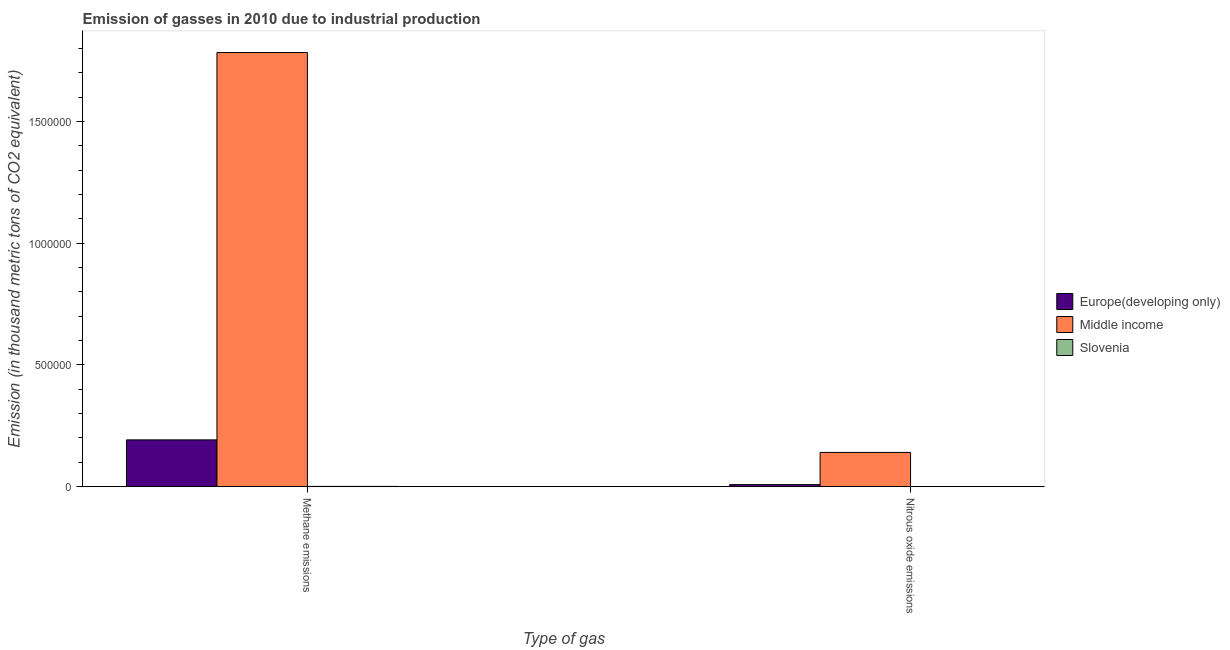Are the number of bars on each tick of the X-axis equal?
Ensure brevity in your answer.  Yes. How many bars are there on the 1st tick from the left?
Offer a very short reply. 3. How many bars are there on the 2nd tick from the right?
Ensure brevity in your answer.  3. What is the label of the 1st group of bars from the left?
Give a very brief answer. Methane emissions. What is the amount of nitrous oxide emissions in Europe(developing only)?
Offer a very short reply. 8539.4. Across all countries, what is the maximum amount of nitrous oxide emissions?
Keep it short and to the point. 1.41e+05. Across all countries, what is the minimum amount of methane emissions?
Your response must be concise. 1225.8. In which country was the amount of methane emissions maximum?
Provide a short and direct response. Middle income. In which country was the amount of methane emissions minimum?
Provide a succinct answer. Slovenia. What is the total amount of methane emissions in the graph?
Make the answer very short. 1.98e+06. What is the difference between the amount of nitrous oxide emissions in Slovenia and that in Middle income?
Keep it short and to the point. -1.41e+05. What is the difference between the amount of methane emissions in Middle income and the amount of nitrous oxide emissions in Europe(developing only)?
Ensure brevity in your answer.  1.77e+06. What is the average amount of nitrous oxide emissions per country?
Your answer should be compact. 4.98e+04. What is the difference between the amount of nitrous oxide emissions and amount of methane emissions in Slovenia?
Offer a terse response. -1091.4. In how many countries, is the amount of methane emissions greater than 100000 thousand metric tons?
Keep it short and to the point. 2. What is the ratio of the amount of methane emissions in Slovenia to that in Middle income?
Your response must be concise. 0. What does the 3rd bar from the left in Methane emissions represents?
Keep it short and to the point. Slovenia. How many bars are there?
Offer a terse response. 6. How many countries are there in the graph?
Make the answer very short. 3. Are the values on the major ticks of Y-axis written in scientific E-notation?
Keep it short and to the point. No. Does the graph contain grids?
Your answer should be very brief. No. Where does the legend appear in the graph?
Provide a succinct answer. Center right. How are the legend labels stacked?
Provide a succinct answer. Vertical. What is the title of the graph?
Offer a terse response. Emission of gasses in 2010 due to industrial production. What is the label or title of the X-axis?
Your response must be concise. Type of gas. What is the label or title of the Y-axis?
Your answer should be very brief. Emission (in thousand metric tons of CO2 equivalent). What is the Emission (in thousand metric tons of CO2 equivalent) of Europe(developing only) in Methane emissions?
Provide a succinct answer. 1.92e+05. What is the Emission (in thousand metric tons of CO2 equivalent) of Middle income in Methane emissions?
Your answer should be compact. 1.78e+06. What is the Emission (in thousand metric tons of CO2 equivalent) of Slovenia in Methane emissions?
Offer a terse response. 1225.8. What is the Emission (in thousand metric tons of CO2 equivalent) in Europe(developing only) in Nitrous oxide emissions?
Your answer should be very brief. 8539.4. What is the Emission (in thousand metric tons of CO2 equivalent) of Middle income in Nitrous oxide emissions?
Offer a very short reply. 1.41e+05. What is the Emission (in thousand metric tons of CO2 equivalent) in Slovenia in Nitrous oxide emissions?
Ensure brevity in your answer.  134.4. Across all Type of gas, what is the maximum Emission (in thousand metric tons of CO2 equivalent) in Europe(developing only)?
Provide a succinct answer. 1.92e+05. Across all Type of gas, what is the maximum Emission (in thousand metric tons of CO2 equivalent) in Middle income?
Ensure brevity in your answer.  1.78e+06. Across all Type of gas, what is the maximum Emission (in thousand metric tons of CO2 equivalent) in Slovenia?
Provide a short and direct response. 1225.8. Across all Type of gas, what is the minimum Emission (in thousand metric tons of CO2 equivalent) in Europe(developing only)?
Keep it short and to the point. 8539.4. Across all Type of gas, what is the minimum Emission (in thousand metric tons of CO2 equivalent) of Middle income?
Offer a very short reply. 1.41e+05. Across all Type of gas, what is the minimum Emission (in thousand metric tons of CO2 equivalent) in Slovenia?
Your answer should be very brief. 134.4. What is the total Emission (in thousand metric tons of CO2 equivalent) in Europe(developing only) in the graph?
Offer a terse response. 2.01e+05. What is the total Emission (in thousand metric tons of CO2 equivalent) of Middle income in the graph?
Offer a very short reply. 1.92e+06. What is the total Emission (in thousand metric tons of CO2 equivalent) in Slovenia in the graph?
Offer a terse response. 1360.2. What is the difference between the Emission (in thousand metric tons of CO2 equivalent) of Europe(developing only) in Methane emissions and that in Nitrous oxide emissions?
Your answer should be compact. 1.84e+05. What is the difference between the Emission (in thousand metric tons of CO2 equivalent) of Middle income in Methane emissions and that in Nitrous oxide emissions?
Ensure brevity in your answer.  1.64e+06. What is the difference between the Emission (in thousand metric tons of CO2 equivalent) in Slovenia in Methane emissions and that in Nitrous oxide emissions?
Your answer should be compact. 1091.4. What is the difference between the Emission (in thousand metric tons of CO2 equivalent) in Europe(developing only) in Methane emissions and the Emission (in thousand metric tons of CO2 equivalent) in Middle income in Nitrous oxide emissions?
Your answer should be very brief. 5.14e+04. What is the difference between the Emission (in thousand metric tons of CO2 equivalent) of Europe(developing only) in Methane emissions and the Emission (in thousand metric tons of CO2 equivalent) of Slovenia in Nitrous oxide emissions?
Provide a succinct answer. 1.92e+05. What is the difference between the Emission (in thousand metric tons of CO2 equivalent) of Middle income in Methane emissions and the Emission (in thousand metric tons of CO2 equivalent) of Slovenia in Nitrous oxide emissions?
Offer a very short reply. 1.78e+06. What is the average Emission (in thousand metric tons of CO2 equivalent) in Europe(developing only) per Type of gas?
Ensure brevity in your answer.  1.00e+05. What is the average Emission (in thousand metric tons of CO2 equivalent) in Middle income per Type of gas?
Give a very brief answer. 9.62e+05. What is the average Emission (in thousand metric tons of CO2 equivalent) of Slovenia per Type of gas?
Make the answer very short. 680.1. What is the difference between the Emission (in thousand metric tons of CO2 equivalent) of Europe(developing only) and Emission (in thousand metric tons of CO2 equivalent) of Middle income in Methane emissions?
Ensure brevity in your answer.  -1.59e+06. What is the difference between the Emission (in thousand metric tons of CO2 equivalent) in Europe(developing only) and Emission (in thousand metric tons of CO2 equivalent) in Slovenia in Methane emissions?
Your answer should be compact. 1.91e+05. What is the difference between the Emission (in thousand metric tons of CO2 equivalent) of Middle income and Emission (in thousand metric tons of CO2 equivalent) of Slovenia in Methane emissions?
Offer a very short reply. 1.78e+06. What is the difference between the Emission (in thousand metric tons of CO2 equivalent) in Europe(developing only) and Emission (in thousand metric tons of CO2 equivalent) in Middle income in Nitrous oxide emissions?
Make the answer very short. -1.32e+05. What is the difference between the Emission (in thousand metric tons of CO2 equivalent) of Europe(developing only) and Emission (in thousand metric tons of CO2 equivalent) of Slovenia in Nitrous oxide emissions?
Make the answer very short. 8405. What is the difference between the Emission (in thousand metric tons of CO2 equivalent) of Middle income and Emission (in thousand metric tons of CO2 equivalent) of Slovenia in Nitrous oxide emissions?
Offer a very short reply. 1.41e+05. What is the ratio of the Emission (in thousand metric tons of CO2 equivalent) of Europe(developing only) in Methane emissions to that in Nitrous oxide emissions?
Provide a succinct answer. 22.5. What is the ratio of the Emission (in thousand metric tons of CO2 equivalent) in Middle income in Methane emissions to that in Nitrous oxide emissions?
Offer a very short reply. 12.67. What is the ratio of the Emission (in thousand metric tons of CO2 equivalent) of Slovenia in Methane emissions to that in Nitrous oxide emissions?
Offer a terse response. 9.12. What is the difference between the highest and the second highest Emission (in thousand metric tons of CO2 equivalent) of Europe(developing only)?
Provide a short and direct response. 1.84e+05. What is the difference between the highest and the second highest Emission (in thousand metric tons of CO2 equivalent) of Middle income?
Your answer should be compact. 1.64e+06. What is the difference between the highest and the second highest Emission (in thousand metric tons of CO2 equivalent) in Slovenia?
Your response must be concise. 1091.4. What is the difference between the highest and the lowest Emission (in thousand metric tons of CO2 equivalent) in Europe(developing only)?
Your answer should be compact. 1.84e+05. What is the difference between the highest and the lowest Emission (in thousand metric tons of CO2 equivalent) of Middle income?
Provide a succinct answer. 1.64e+06. What is the difference between the highest and the lowest Emission (in thousand metric tons of CO2 equivalent) of Slovenia?
Your answer should be compact. 1091.4. 